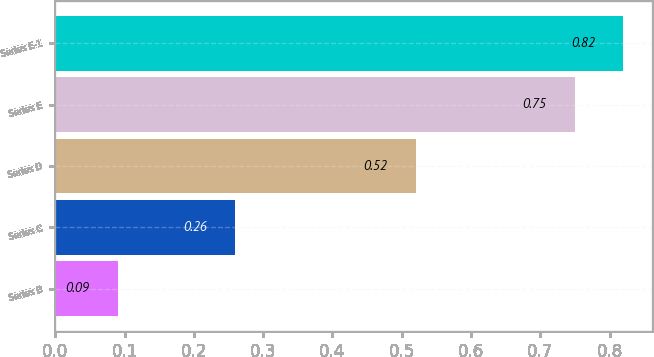Convert chart to OTSL. <chart><loc_0><loc_0><loc_500><loc_500><bar_chart><fcel>Series B<fcel>Series C<fcel>Series D<fcel>Series E<fcel>Series E-1<nl><fcel>0.09<fcel>0.26<fcel>0.52<fcel>0.75<fcel>0.82<nl></chart> 